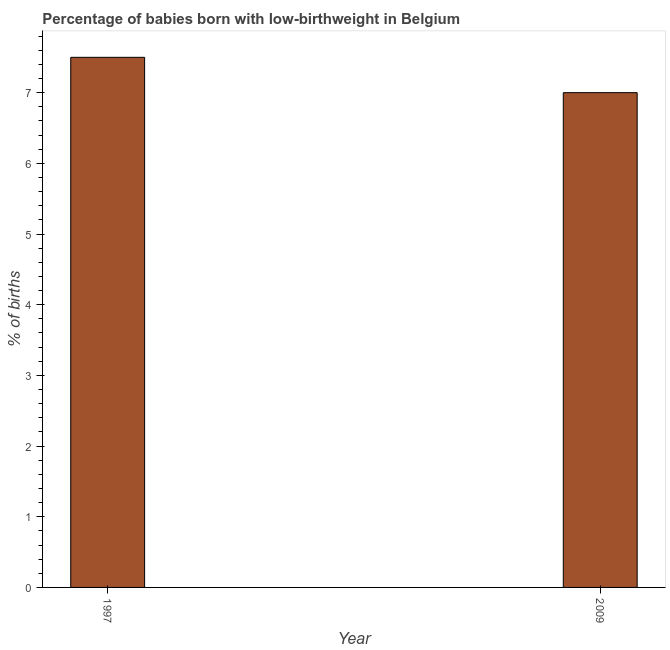What is the title of the graph?
Your response must be concise. Percentage of babies born with low-birthweight in Belgium. What is the label or title of the X-axis?
Make the answer very short. Year. What is the label or title of the Y-axis?
Provide a short and direct response. % of births. What is the percentage of babies who were born with low-birthweight in 2009?
Make the answer very short. 7. Across all years, what is the maximum percentage of babies who were born with low-birthweight?
Your answer should be very brief. 7.5. In which year was the percentage of babies who were born with low-birthweight maximum?
Give a very brief answer. 1997. What is the sum of the percentage of babies who were born with low-birthweight?
Provide a short and direct response. 14.5. What is the difference between the percentage of babies who were born with low-birthweight in 1997 and 2009?
Provide a short and direct response. 0.5. What is the average percentage of babies who were born with low-birthweight per year?
Provide a short and direct response. 7.25. What is the median percentage of babies who were born with low-birthweight?
Provide a succinct answer. 7.25. In how many years, is the percentage of babies who were born with low-birthweight greater than 6.2 %?
Provide a short and direct response. 2. What is the ratio of the percentage of babies who were born with low-birthweight in 1997 to that in 2009?
Offer a terse response. 1.07. Is the percentage of babies who were born with low-birthweight in 1997 less than that in 2009?
Your response must be concise. No. In how many years, is the percentage of babies who were born with low-birthweight greater than the average percentage of babies who were born with low-birthweight taken over all years?
Your answer should be very brief. 1. How many bars are there?
Make the answer very short. 2. What is the difference between two consecutive major ticks on the Y-axis?
Keep it short and to the point. 1. Are the values on the major ticks of Y-axis written in scientific E-notation?
Provide a short and direct response. No. What is the % of births of 2009?
Your response must be concise. 7. What is the ratio of the % of births in 1997 to that in 2009?
Provide a succinct answer. 1.07. 